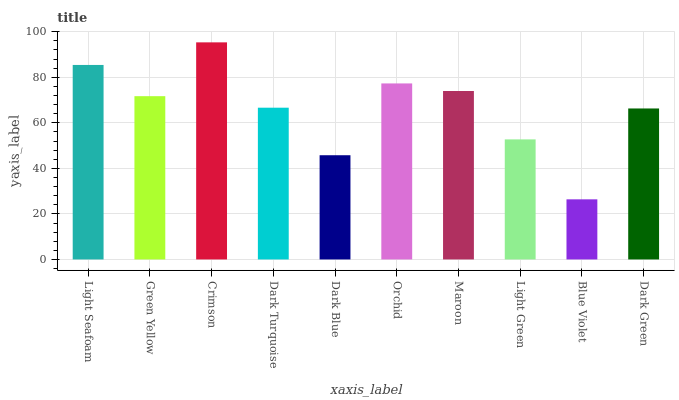Is Blue Violet the minimum?
Answer yes or no. Yes. Is Crimson the maximum?
Answer yes or no. Yes. Is Green Yellow the minimum?
Answer yes or no. No. Is Green Yellow the maximum?
Answer yes or no. No. Is Light Seafoam greater than Green Yellow?
Answer yes or no. Yes. Is Green Yellow less than Light Seafoam?
Answer yes or no. Yes. Is Green Yellow greater than Light Seafoam?
Answer yes or no. No. Is Light Seafoam less than Green Yellow?
Answer yes or no. No. Is Green Yellow the high median?
Answer yes or no. Yes. Is Dark Turquoise the low median?
Answer yes or no. Yes. Is Dark Green the high median?
Answer yes or no. No. Is Crimson the low median?
Answer yes or no. No. 